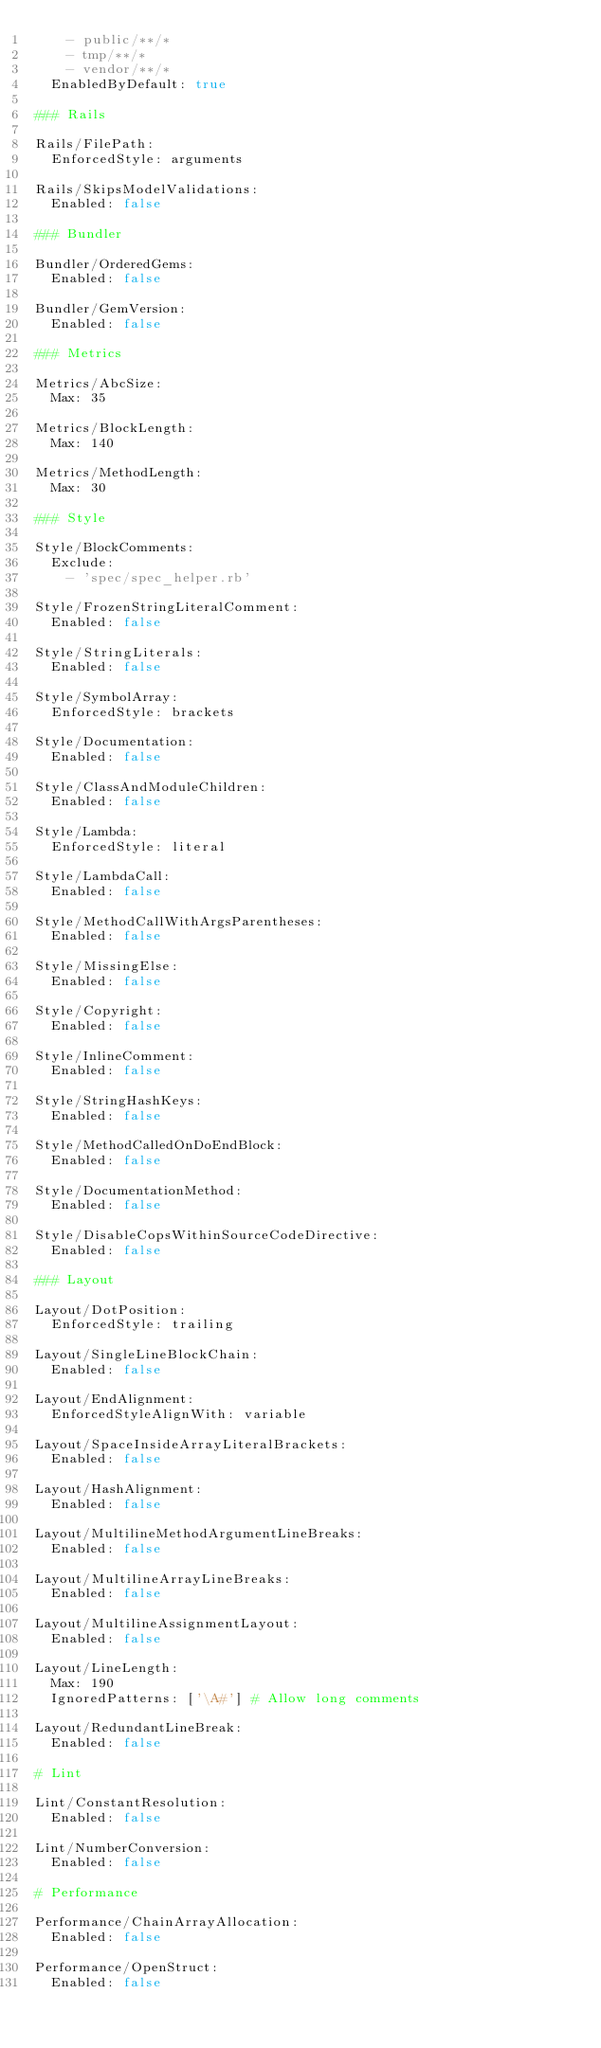<code> <loc_0><loc_0><loc_500><loc_500><_YAML_>    - public/**/*
    - tmp/**/*
    - vendor/**/*
  EnabledByDefault: true

### Rails

Rails/FilePath:
  EnforcedStyle: arguments

Rails/SkipsModelValidations:
  Enabled: false

### Bundler

Bundler/OrderedGems:
  Enabled: false

Bundler/GemVersion:
  Enabled: false

### Metrics

Metrics/AbcSize:
  Max: 35

Metrics/BlockLength:
  Max: 140

Metrics/MethodLength:
  Max: 30

### Style

Style/BlockComments:
  Exclude:
    - 'spec/spec_helper.rb'

Style/FrozenStringLiteralComment:
  Enabled: false

Style/StringLiterals:
  Enabled: false

Style/SymbolArray:
  EnforcedStyle: brackets

Style/Documentation:
  Enabled: false

Style/ClassAndModuleChildren:
  Enabled: false

Style/Lambda:
  EnforcedStyle: literal

Style/LambdaCall:
  Enabled: false

Style/MethodCallWithArgsParentheses:
  Enabled: false

Style/MissingElse:
  Enabled: false

Style/Copyright:
  Enabled: false

Style/InlineComment:
  Enabled: false

Style/StringHashKeys:
  Enabled: false

Style/MethodCalledOnDoEndBlock:
  Enabled: false

Style/DocumentationMethod:
  Enabled: false

Style/DisableCopsWithinSourceCodeDirective:
  Enabled: false

### Layout

Layout/DotPosition:
  EnforcedStyle: trailing

Layout/SingleLineBlockChain:
  Enabled: false

Layout/EndAlignment:
  EnforcedStyleAlignWith: variable

Layout/SpaceInsideArrayLiteralBrackets:
  Enabled: false

Layout/HashAlignment:
  Enabled: false

Layout/MultilineMethodArgumentLineBreaks:
  Enabled: false

Layout/MultilineArrayLineBreaks:
  Enabled: false

Layout/MultilineAssignmentLayout:
  Enabled: false

Layout/LineLength:
  Max: 190
  IgnoredPatterns: ['\A#'] # Allow long comments

Layout/RedundantLineBreak:
  Enabled: false

# Lint

Lint/ConstantResolution:
  Enabled: false

Lint/NumberConversion:
  Enabled: false

# Performance

Performance/ChainArrayAllocation:
  Enabled: false

Performance/OpenStruct:
  Enabled: false
</code> 